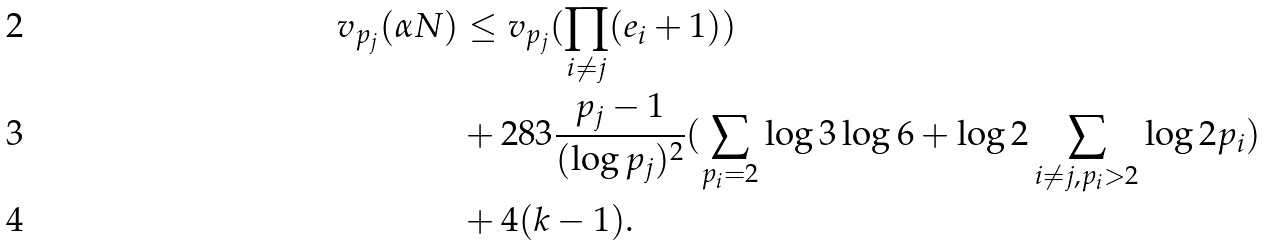Convert formula to latex. <formula><loc_0><loc_0><loc_500><loc_500>v _ { p _ { j } } ( \alpha N ) & \leq v _ { p _ { j } } ( \prod _ { i \neq j } ( e _ { i } + 1 ) ) \\ & + 2 8 3 \frac { p _ { j } - 1 } { ( \log p _ { j } ) ^ { 2 } } ( \sum _ { p _ { i } = 2 } \log 3 \log 6 + \log 2 \sum _ { i \neq j , p _ { i } > 2 } \log 2 p _ { i } ) \\ & + 4 ( k - 1 ) .</formula> 